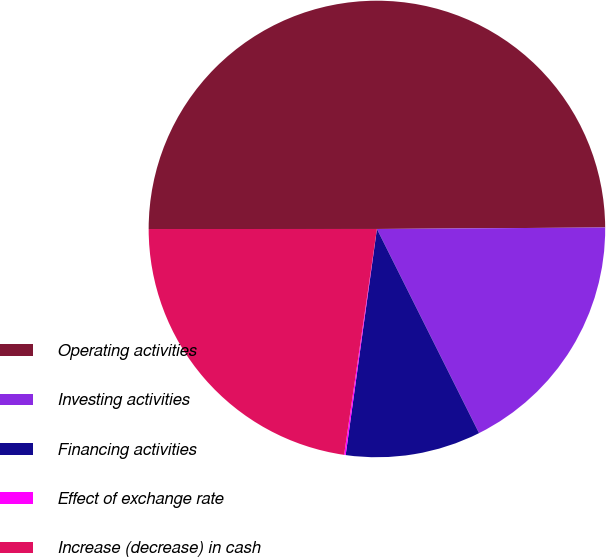<chart> <loc_0><loc_0><loc_500><loc_500><pie_chart><fcel>Operating activities<fcel>Investing activities<fcel>Financing activities<fcel>Effect of exchange rate<fcel>Increase (decrease) in cash<nl><fcel>49.9%<fcel>17.72%<fcel>9.57%<fcel>0.11%<fcel>22.7%<nl></chart> 